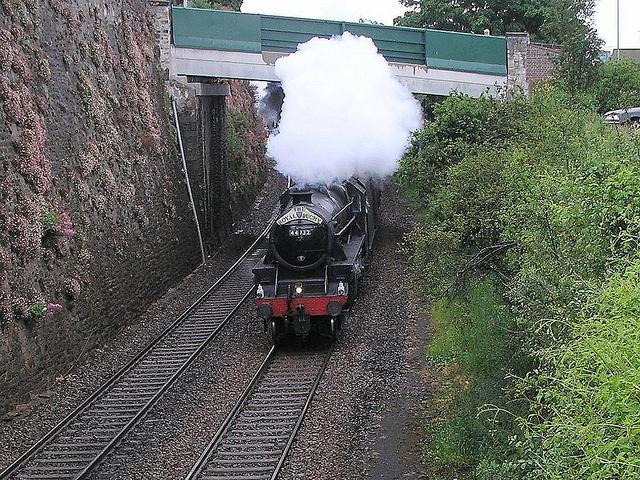Is this a summer scene?
Keep it brief. Yes. Is this train traveling under a cloud?
Quick response, please. No. What is creating the cloud above the train?
Concise answer only. Steam. 